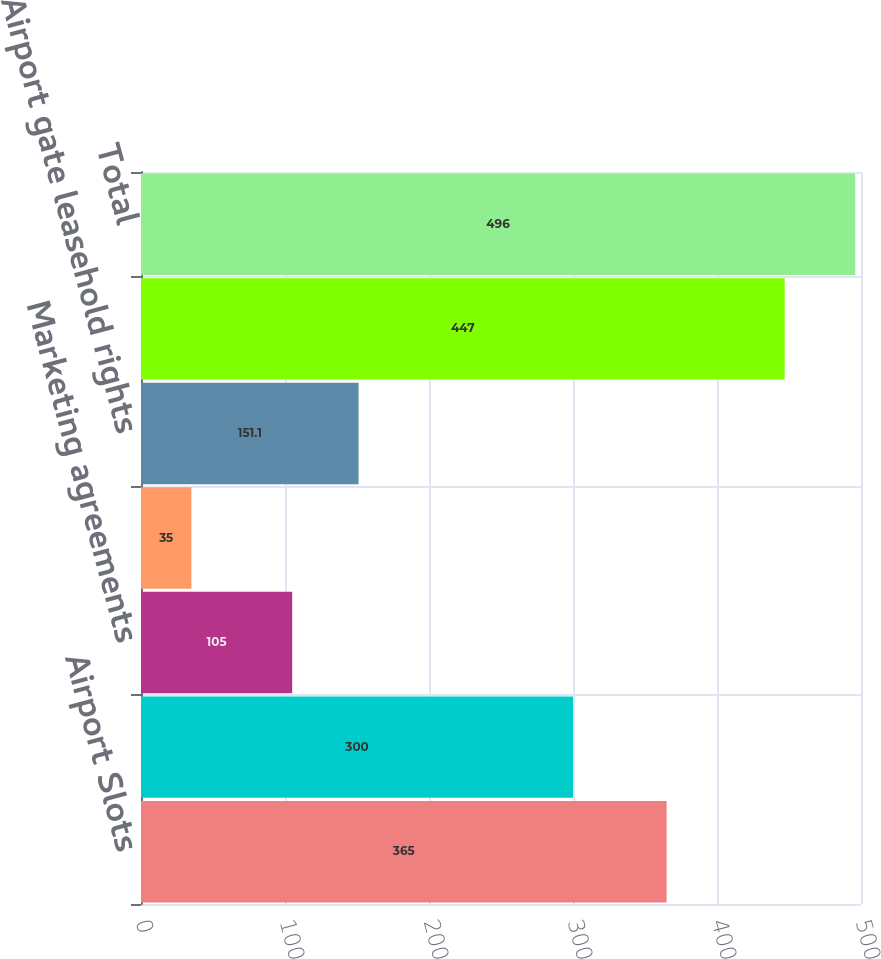Convert chart. <chart><loc_0><loc_0><loc_500><loc_500><bar_chart><fcel>Airport Slots<fcel>Customer relationships<fcel>Marketing agreements<fcel>Tradenames<fcel>Airport gate leasehold rights<fcel>Accumulated amortization<fcel>Total<nl><fcel>365<fcel>300<fcel>105<fcel>35<fcel>151.1<fcel>447<fcel>496<nl></chart> 